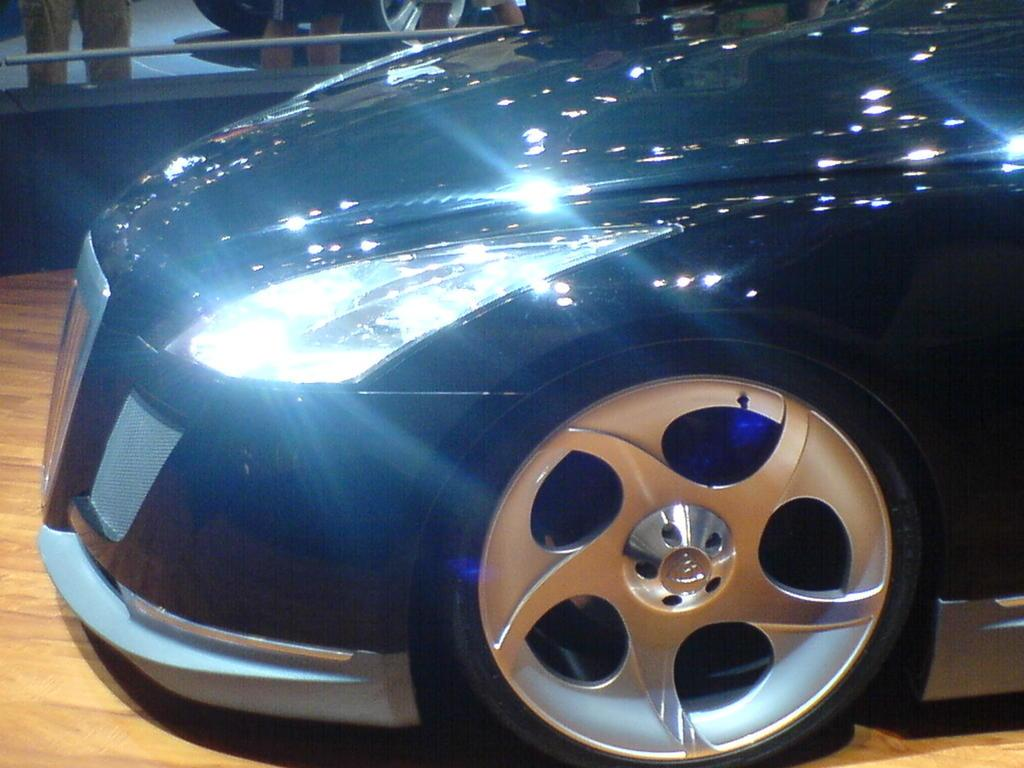What is the main subject of the image? There is a vehicle in the image. Can you describe the position of the vehicle? The vehicle is on a surface. What can be seen in the background of the image? There is a wall, a rod, and legs of people in the background of the image. Are there any other vehicle-related elements visible in the image? Yes, there are wheels of a vehicle in the background of the image. What type of lace is being used to decorate the vehicle in the image? There is no lace present in the image; it features a vehicle with wheels and a background with a wall, a rod, and legs of people. 